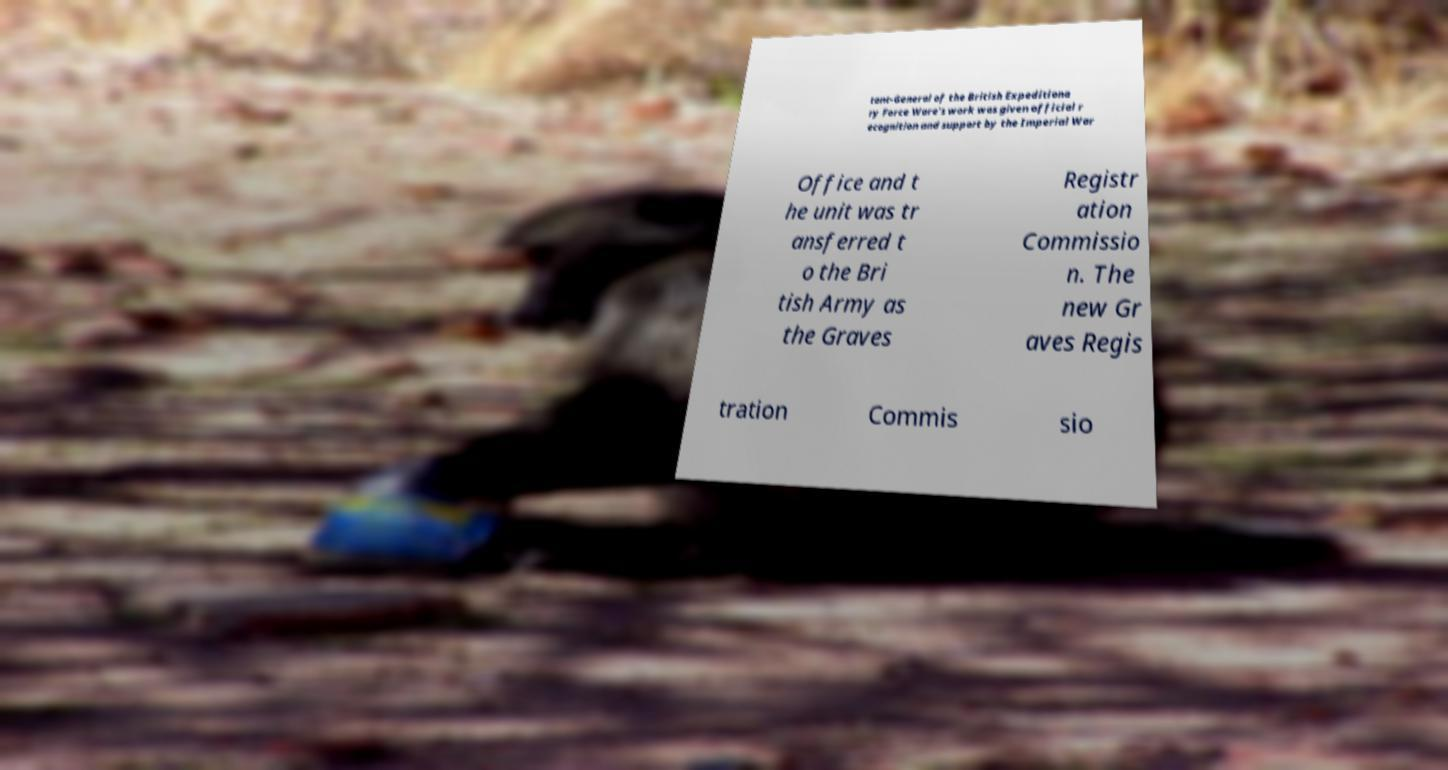Please read and relay the text visible in this image. What does it say? tant-General of the British Expeditiona ry Force Ware's work was given official r ecognition and support by the Imperial War Office and t he unit was tr ansferred t o the Bri tish Army as the Graves Registr ation Commissio n. The new Gr aves Regis tration Commis sio 